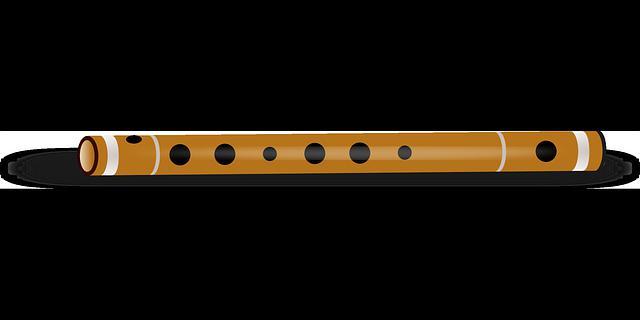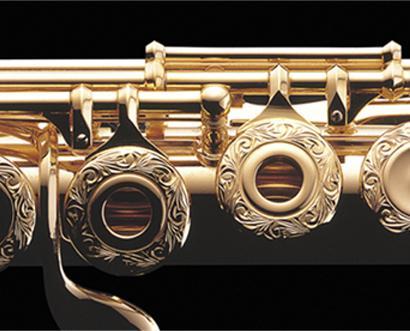The first image is the image on the left, the second image is the image on the right. Analyze the images presented: Is the assertion "One image shows a horizontal row of round metal keys with open centers on a tube-shaped metal instrument, and the other image shows one wooden flute with holes but no keys and several stripes around it." valid? Answer yes or no. Yes. The first image is the image on the left, the second image is the image on the right. Evaluate the accuracy of this statement regarding the images: "There is a single instrument in each of the images, one of which is a flute.". Is it true? Answer yes or no. Yes. 